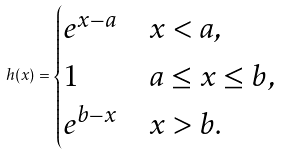Convert formula to latex. <formula><loc_0><loc_0><loc_500><loc_500>h ( x ) = \begin{cases} e ^ { x - a } & x < a , \\ 1 & a \leq x \leq b , \\ e ^ { b - x } & x > b . \end{cases}</formula> 